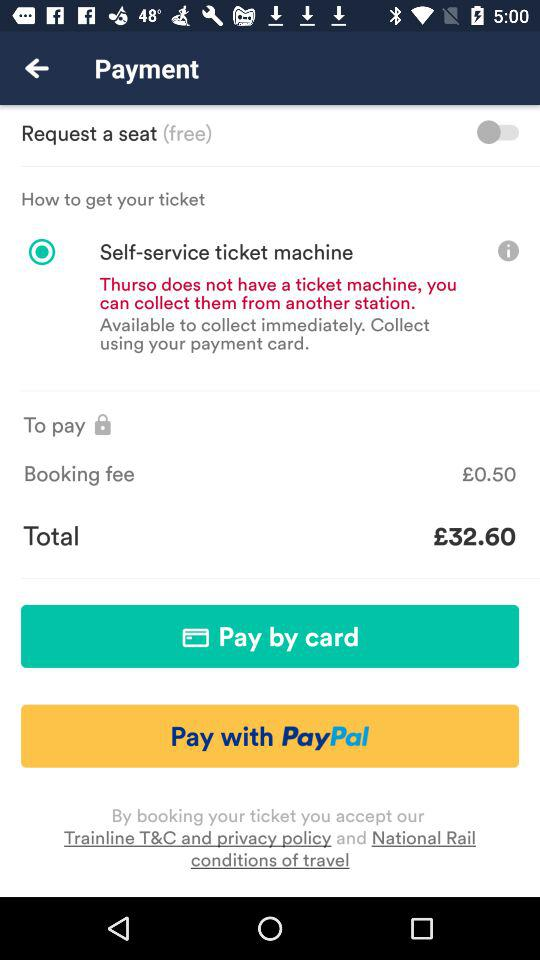What is the total price? The total price is £32.60. 